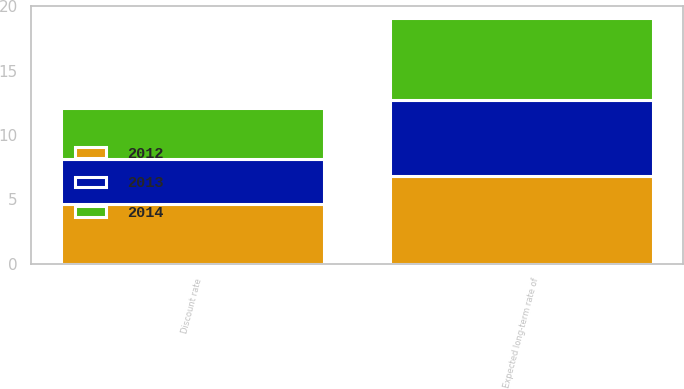<chart> <loc_0><loc_0><loc_500><loc_500><stacked_bar_chart><ecel><fcel>Discount rate<fcel>Expected long-term rate of<nl><fcel>2012<fcel>4.68<fcel>6.85<nl><fcel>2013<fcel>3.43<fcel>5.9<nl><fcel>2014<fcel>3.98<fcel>6.3<nl></chart> 